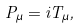Convert formula to latex. <formula><loc_0><loc_0><loc_500><loc_500>P _ { \mu } = i T _ { \mu } ,</formula> 